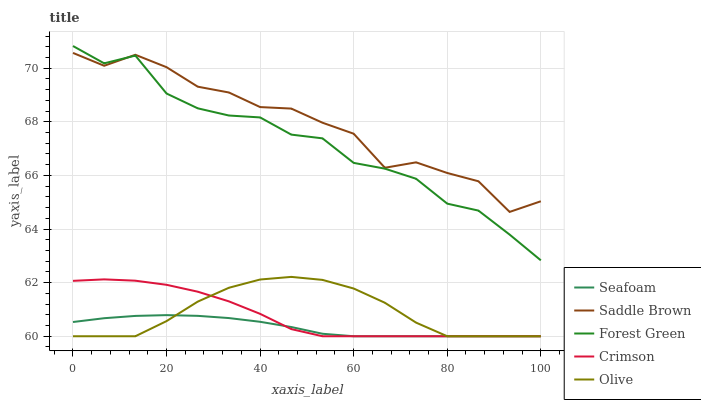Does Seafoam have the minimum area under the curve?
Answer yes or no. Yes. Does Saddle Brown have the maximum area under the curve?
Answer yes or no. Yes. Does Olive have the minimum area under the curve?
Answer yes or no. No. Does Olive have the maximum area under the curve?
Answer yes or no. No. Is Seafoam the smoothest?
Answer yes or no. Yes. Is Saddle Brown the roughest?
Answer yes or no. Yes. Is Olive the smoothest?
Answer yes or no. No. Is Olive the roughest?
Answer yes or no. No. Does Forest Green have the lowest value?
Answer yes or no. No. Does Olive have the highest value?
Answer yes or no. No. Is Olive less than Forest Green?
Answer yes or no. Yes. Is Saddle Brown greater than Olive?
Answer yes or no. Yes. Does Olive intersect Forest Green?
Answer yes or no. No. 